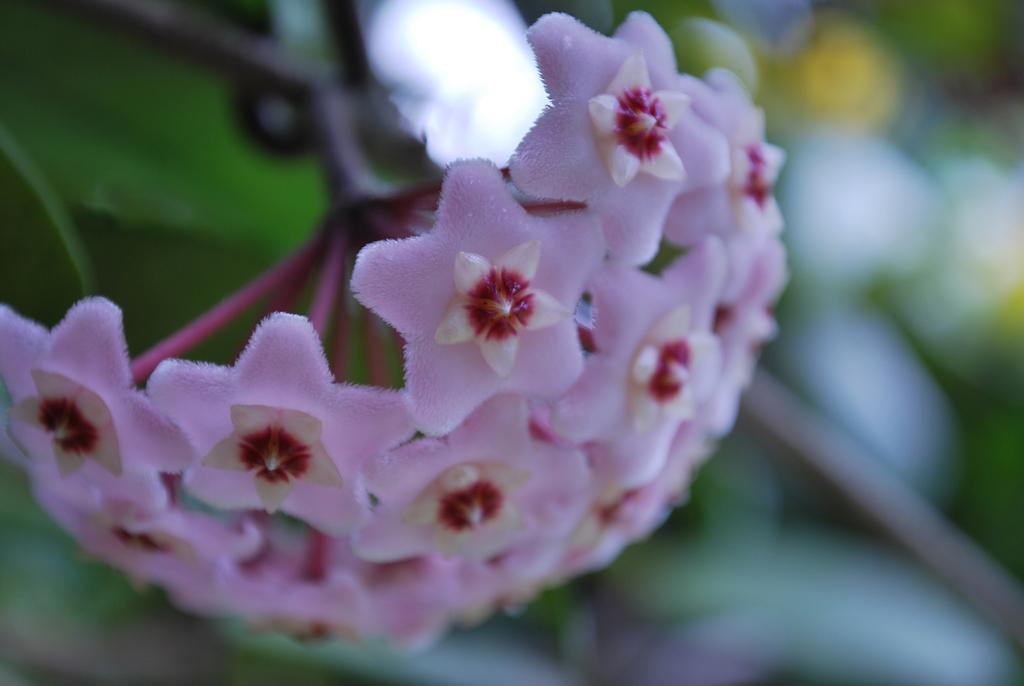What type of living organisms can be seen in the image? There are flowers in the image. Can you describe the background of the image? The background of the image is blurred. What is the purpose of the daughter in the image? There is no daughter present in the image; it only features flowers and a blurred background. 